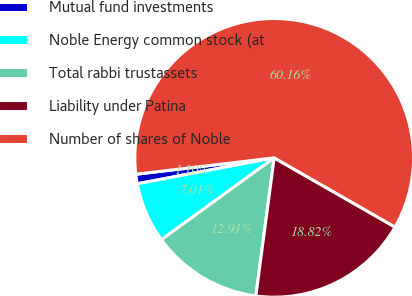Convert chart to OTSL. <chart><loc_0><loc_0><loc_500><loc_500><pie_chart><fcel>Mutual fund investments<fcel>Noble Energy common stock (at<fcel>Total rabbi trustassets<fcel>Liability under Patina<fcel>Number of shares of Noble<nl><fcel>1.1%<fcel>7.01%<fcel>12.91%<fcel>18.82%<fcel>60.16%<nl></chart> 